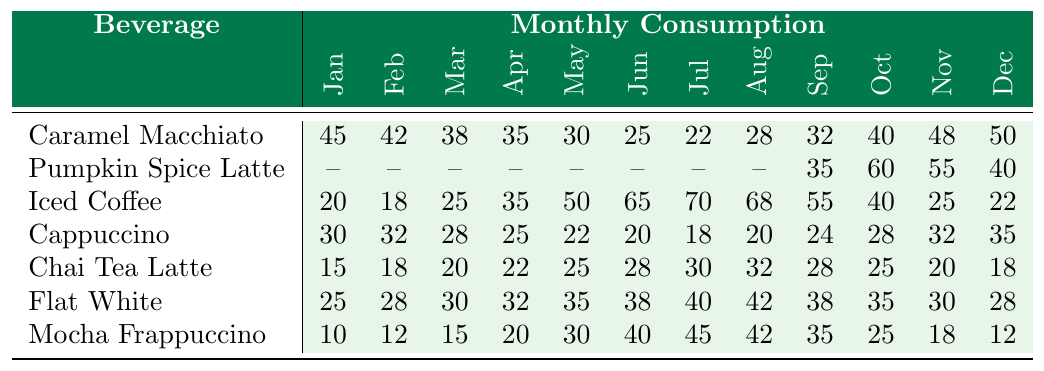What is the highest monthly consumption of Iced Coffee? The table shows that the highest value for Iced Coffee is 70, which occurs in July.
Answer: 70 In which month did the Caramel Macchiato have the lowest sales? The lowest sales for Caramel Macchiato is 22, which occurs in July.
Answer: July How many more cups of Flat White were consumed in June compared to March? Flat White's consumption in June is 38 and in March is 30. The difference is 38 - 30 = 8.
Answer: 8 True or False: The Pumpkin Spice Latte was consumed in every month. The table indicates that Pumpkin Spice Latte has no sales recorded from January to August; hence it was not consumed in every month.
Answer: False What is the total consumption of Chai Tea Latte across all months? Adding all values for Chai Tea Latte gives 15 + 18 + 20 + 22 + 25 + 28 + 30 + 32 + 28 + 25 + 20 + 18 which totals  18 + 22 + 25 + 28 + 30 + 32 + 28 + 25 + 20 + 18 =  15 + 46 + 69 + 50 + 250 = 45 + 130 = 370.
Answer: 370 Which beverage had consistent sales of 30 or more in the summer months (June, July, August)? By looking at the table for the summer months, only Iced Coffee (65, 70, 68) and Flat White (38, 40, 42) had sales of 30 or more.
Answer: Iced Coffee and Flat White What is the average monthly consumption of Mocha Frappuccino? The total consumption for Mocha Frappuccino is 10 + 12 + 15 + 20 + 30 + 40 + 45 + 42 + 35 + 25 + 18 + 12 = 389. There are 12 months, so the average is 389 / 12 ≈ 32.42.
Answer: 32.42 Which beverage shows the highest growth from April to August? From April to August, Iced Coffee grows from 35 to 68, a growth of 33. In comparison, Flat White grows from 32 to 42, a growth of 10, and Chai Tea Latte grows from 22 to 32, also a growth of 10. Clearly, Iced Coffee has the highest growth with a total of 33.
Answer: Iced Coffee What was the consumption trend for Cappuccino throughout the year? Analyzing the column data, it starts at 30 in January, fluctuates slightly but ultimately ends at 35 in December, indicating a modest increase.
Answer: Slight increase In which month did Chai Tea Latte have its highest consumption? Chai Tea Latte peaked at 32 cups in August.
Answer: August Which beverage has the second-highest total consumption in December? In December, Caramel Macchiato has 50 cups, and Iced Coffee has 22 cups. Thus, following Caramel Macchiato, the second highest is Cappuccino with 35 cups.
Answer: Cappuccino 